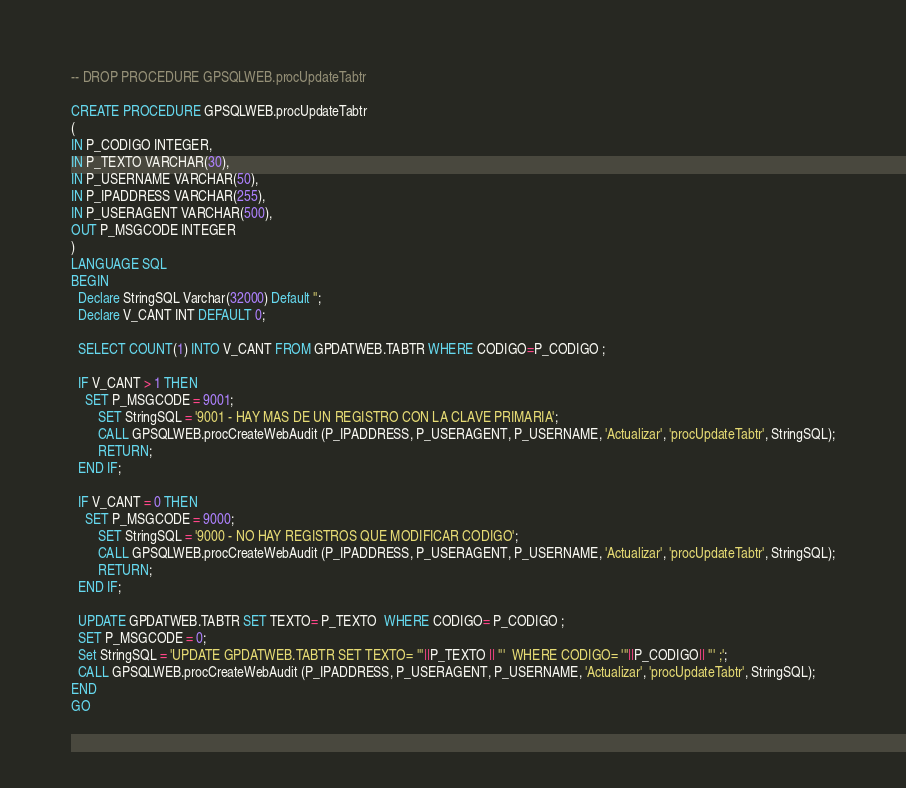Convert code to text. <code><loc_0><loc_0><loc_500><loc_500><_SQL_>-- DROP PROCEDURE GPSQLWEB.procUpdateTabtr
    
CREATE PROCEDURE GPSQLWEB.procUpdateTabtr
(
IN P_CODIGO INTEGER,
IN P_TEXTO VARCHAR(30),
IN P_USERNAME VARCHAR(50),
IN P_IPADDRESS VARCHAR(255),
IN P_USERAGENT VARCHAR(500),
OUT P_MSGCODE INTEGER
)
LANGUAGE SQL
BEGIN
  Declare StringSQL Varchar(32000) Default '';
  Declare V_CANT INT DEFAULT 0;
  
  SELECT COUNT(1) INTO V_CANT FROM GPDATWEB.TABTR WHERE CODIGO=P_CODIGO ;

  IF V_CANT > 1 THEN
	SET P_MSGCODE = 9001;
        SET StringSQL = '9001 - HAY MAS DE UN REGISTRO CON LA CLAVE PRIMARIA';
        CALL GPSQLWEB.procCreateWebAudit (P_IPADDRESS, P_USERAGENT, P_USERNAME, 'Actualizar', 'procUpdateTabtr', StringSQL);
        RETURN;
  END IF;

  IF V_CANT = 0 THEN
	SET P_MSGCODE = 9000;
        SET StringSQL = '9000 - NO HAY REGISTROS QUE MODIFICAR CODIGO';
        CALL GPSQLWEB.procCreateWebAudit (P_IPADDRESS, P_USERAGENT, P_USERNAME, 'Actualizar', 'procUpdateTabtr', StringSQL);
        RETURN;
  END IF;

  UPDATE GPDATWEB.TABTR SET TEXTO= P_TEXTO  WHERE CODIGO= P_CODIGO ;
  SET P_MSGCODE = 0;    
  Set StringSQL = 'UPDATE GPDATWEB.TABTR SET TEXTO= '''||P_TEXTO || '''  WHERE CODIGO= '''||P_CODIGO|| ''' ;';
  CALL GPSQLWEB.procCreateWebAudit (P_IPADDRESS, P_USERAGENT, P_USERNAME, 'Actualizar', 'procUpdateTabtr', StringSQL);
END
GO


</code> 